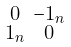<formula> <loc_0><loc_0><loc_500><loc_500>\begin{smallmatrix} 0 & - 1 _ { n } \\ 1 _ { n } & 0 \end{smallmatrix}</formula> 